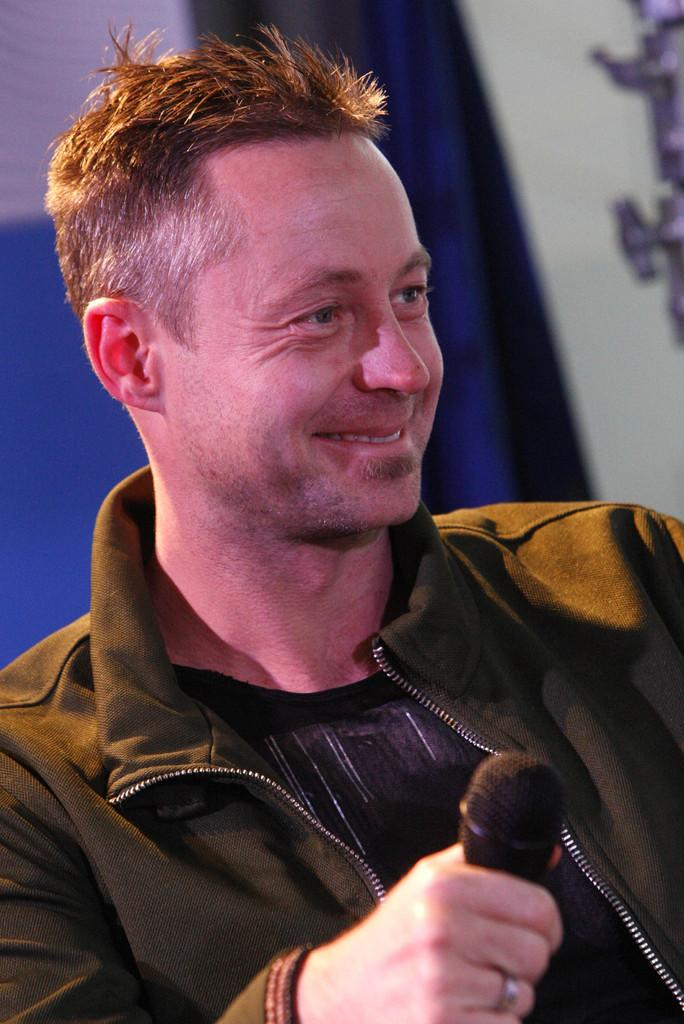What is the man in the image doing? The man is standing in the image and smiling. What is the man holding in his hand? The man is holding a microphone in his hand. What can be seen behind the man in the image? There is a curtain to the wall behind him. What type of weather can be seen in the image? The image does not depict any weather conditions; it is focused on the man and his surroundings. How many houses are visible in the image? There are no houses visible in the image; it features a man standing with a microphone and a curtain to the wall behind him. 